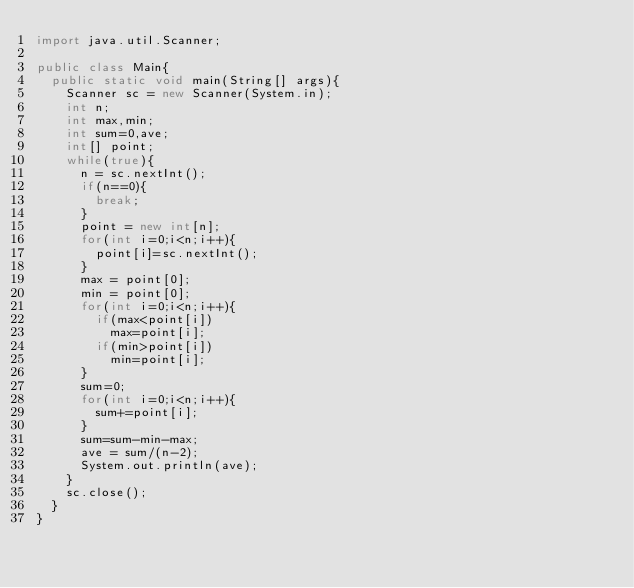Convert code to text. <code><loc_0><loc_0><loc_500><loc_500><_Java_>import java.util.Scanner;

public class Main{	
	public static void main(String[] args){
		Scanner sc = new Scanner(System.in);
		int n;
		int max,min;
		int sum=0,ave;
		int[] point;
		while(true){
			n = sc.nextInt();
			if(n==0){
				break;
			}
			point = new int[n];
			for(int i=0;i<n;i++){
				point[i]=sc.nextInt();
			}
			max = point[0];
			min = point[0];
			for(int i=0;i<n;i++){
				if(max<point[i])
					max=point[i];
				if(min>point[i])
					min=point[i];
			}
			sum=0;
			for(int i=0;i<n;i++){
				sum+=point[i];
			}
			sum=sum-min-max;
			ave = sum/(n-2);
			System.out.println(ave);	
		}
		sc.close();
	}
}
</code> 